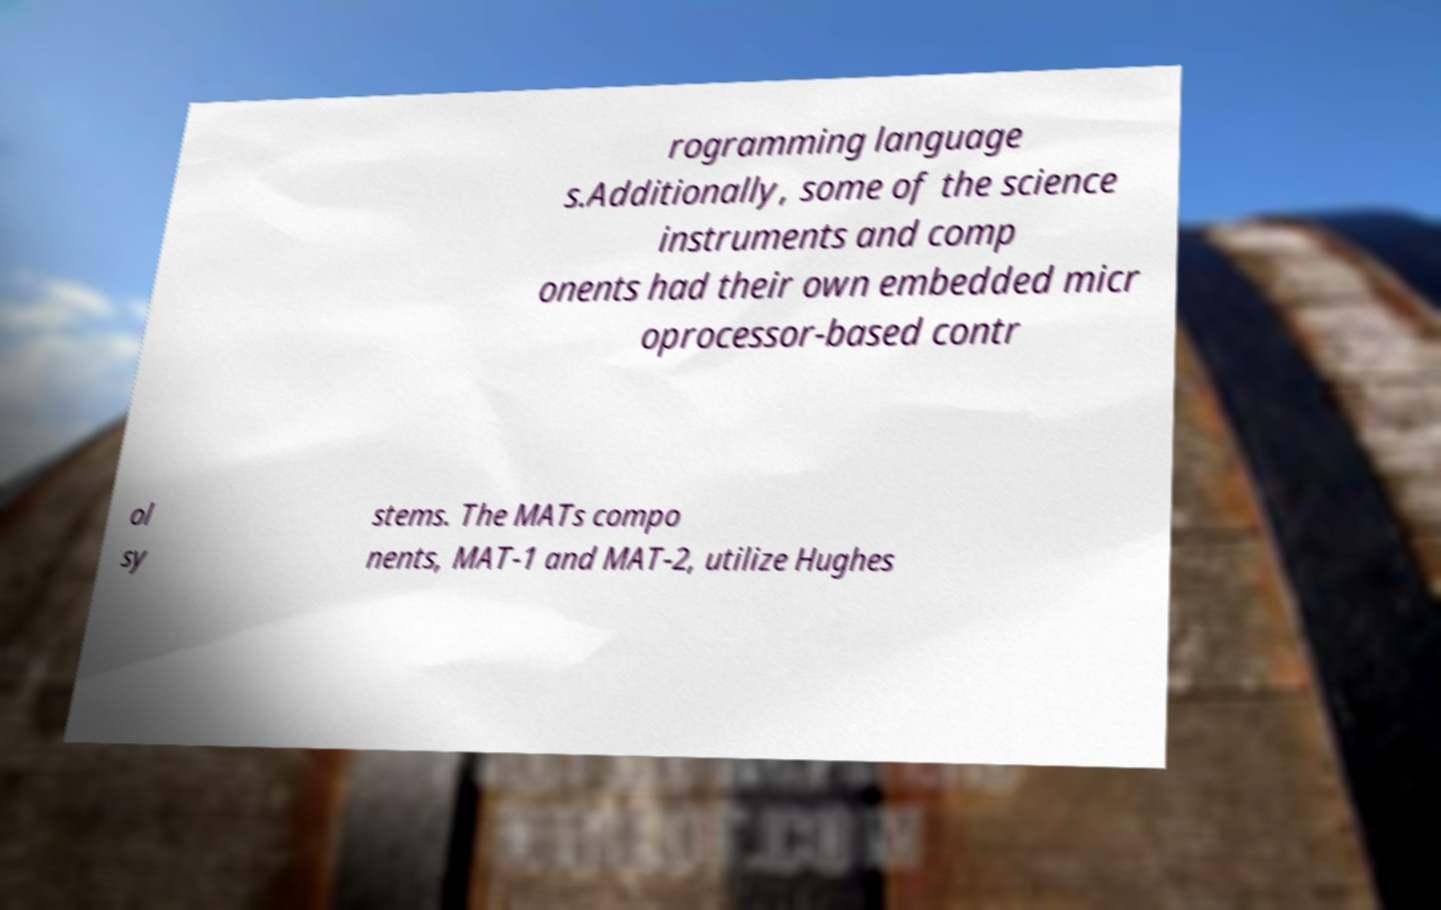Can you read and provide the text displayed in the image?This photo seems to have some interesting text. Can you extract and type it out for me? rogramming language s.Additionally, some of the science instruments and comp onents had their own embedded micr oprocessor-based contr ol sy stems. The MATs compo nents, MAT-1 and MAT-2, utilize Hughes 